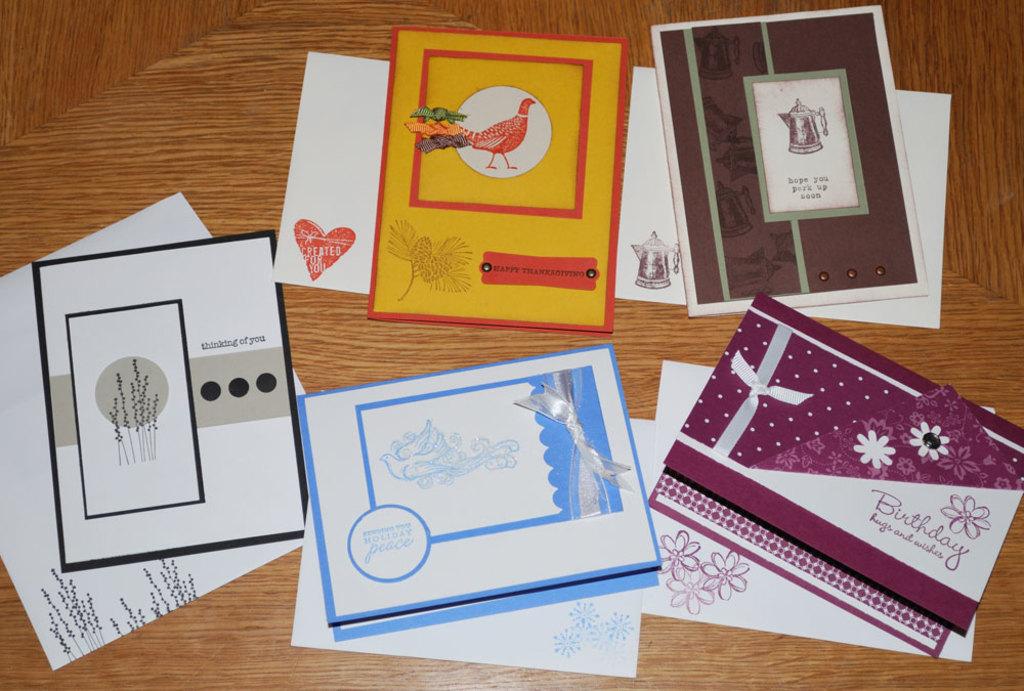What kind of event is the card at the bottom right for?
Your answer should be compact. Birthday. Is that left card a "thinking of you" card?
Your answer should be very brief. Yes. 